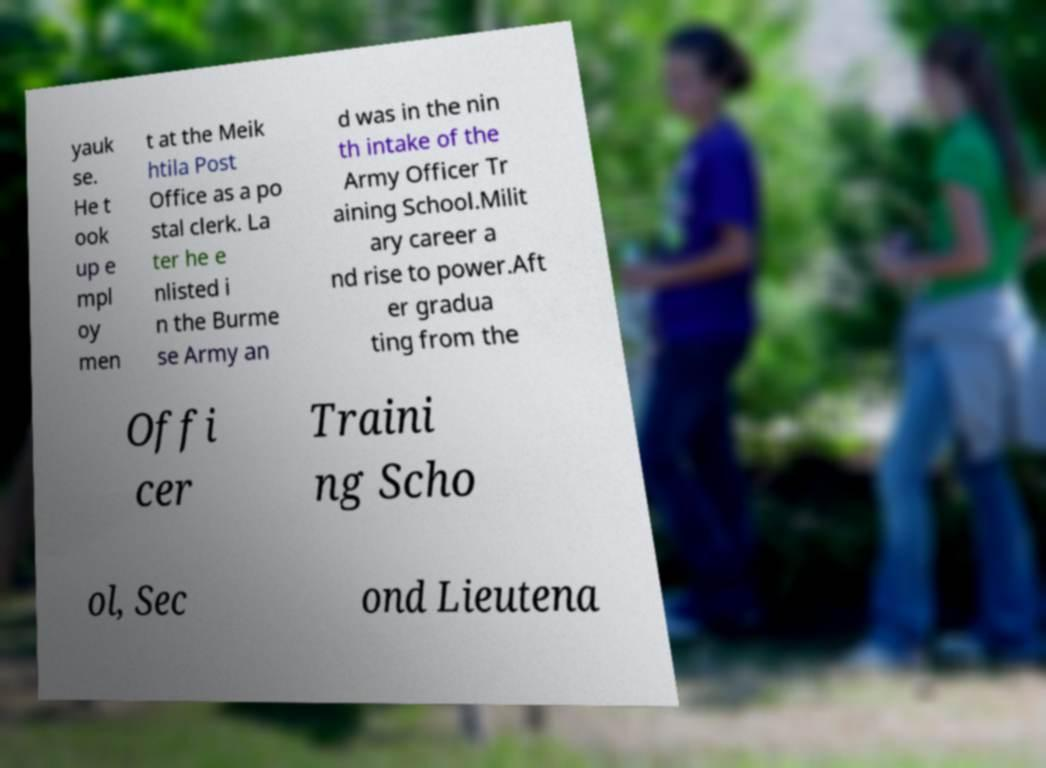Please read and relay the text visible in this image. What does it say? yauk se. He t ook up e mpl oy men t at the Meik htila Post Office as a po stal clerk. La ter he e nlisted i n the Burme se Army an d was in the nin th intake of the Army Officer Tr aining School.Milit ary career a nd rise to power.Aft er gradua ting from the Offi cer Traini ng Scho ol, Sec ond Lieutena 